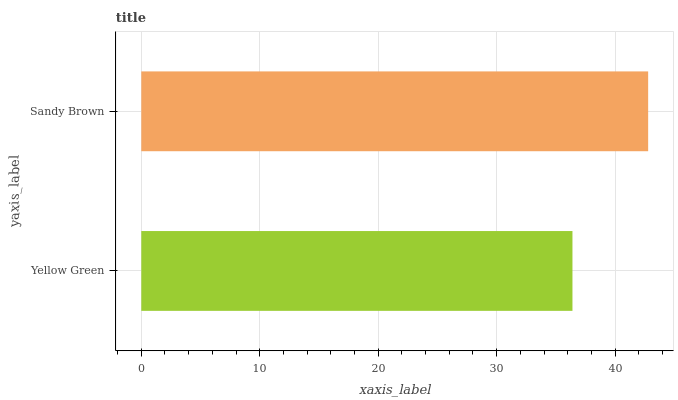Is Yellow Green the minimum?
Answer yes or no. Yes. Is Sandy Brown the maximum?
Answer yes or no. Yes. Is Sandy Brown the minimum?
Answer yes or no. No. Is Sandy Brown greater than Yellow Green?
Answer yes or no. Yes. Is Yellow Green less than Sandy Brown?
Answer yes or no. Yes. Is Yellow Green greater than Sandy Brown?
Answer yes or no. No. Is Sandy Brown less than Yellow Green?
Answer yes or no. No. Is Sandy Brown the high median?
Answer yes or no. Yes. Is Yellow Green the low median?
Answer yes or no. Yes. Is Yellow Green the high median?
Answer yes or no. No. Is Sandy Brown the low median?
Answer yes or no. No. 